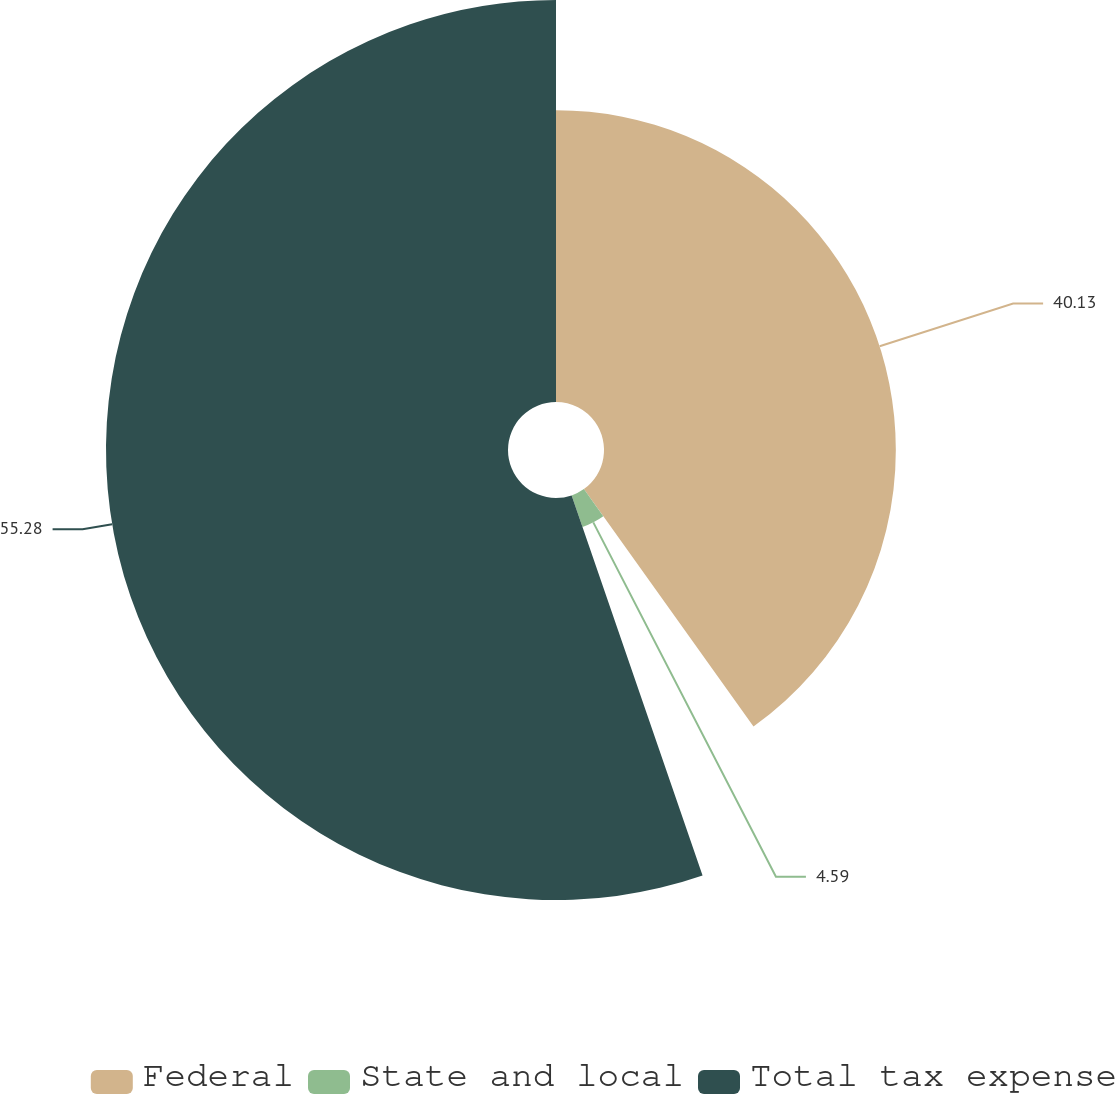<chart> <loc_0><loc_0><loc_500><loc_500><pie_chart><fcel>Federal<fcel>State and local<fcel>Total tax expense<nl><fcel>40.13%<fcel>4.59%<fcel>55.28%<nl></chart> 